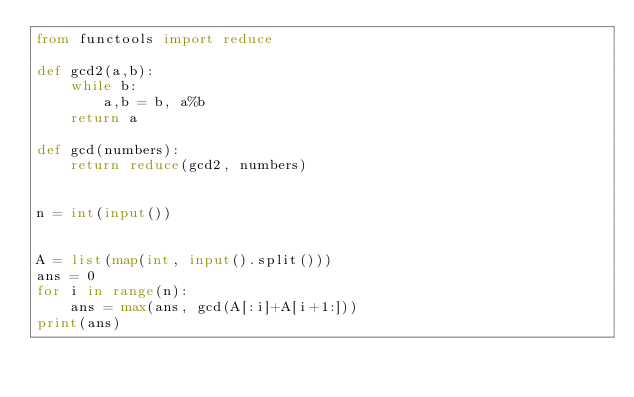Convert code to text. <code><loc_0><loc_0><loc_500><loc_500><_Python_>from functools import reduce

def gcd2(a,b):
    while b:
        a,b = b, a%b
    return a

def gcd(numbers):
    return reduce(gcd2, numbers)


n = int(input())


A = list(map(int, input().split()))
ans = 0
for i in range(n):
    ans = max(ans, gcd(A[:i]+A[i+1:]))
print(ans)</code> 